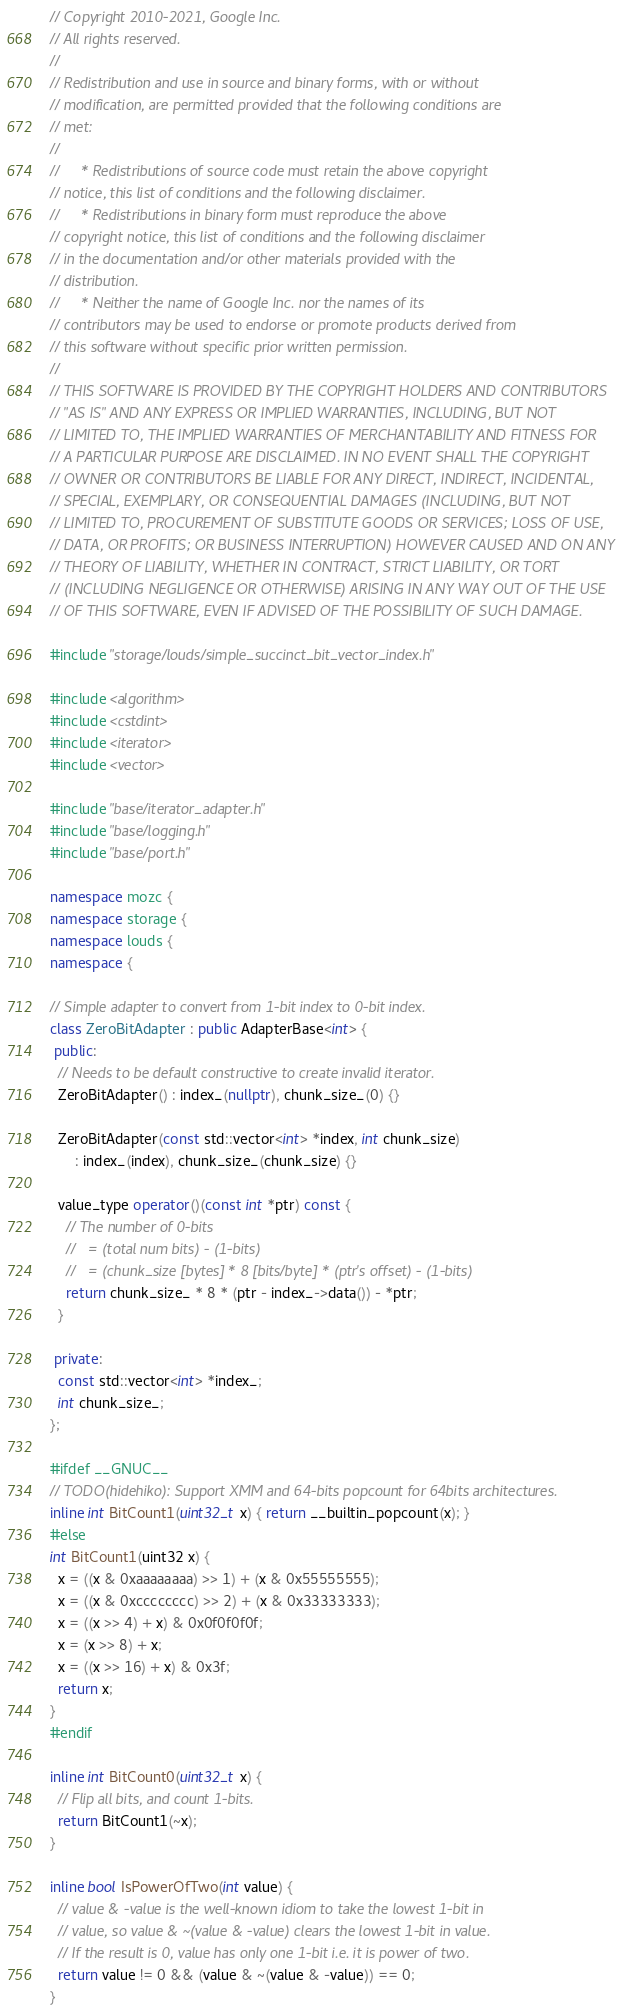<code> <loc_0><loc_0><loc_500><loc_500><_C++_>// Copyright 2010-2021, Google Inc.
// All rights reserved.
//
// Redistribution and use in source and binary forms, with or without
// modification, are permitted provided that the following conditions are
// met:
//
//     * Redistributions of source code must retain the above copyright
// notice, this list of conditions and the following disclaimer.
//     * Redistributions in binary form must reproduce the above
// copyright notice, this list of conditions and the following disclaimer
// in the documentation and/or other materials provided with the
// distribution.
//     * Neither the name of Google Inc. nor the names of its
// contributors may be used to endorse or promote products derived from
// this software without specific prior written permission.
//
// THIS SOFTWARE IS PROVIDED BY THE COPYRIGHT HOLDERS AND CONTRIBUTORS
// "AS IS" AND ANY EXPRESS OR IMPLIED WARRANTIES, INCLUDING, BUT NOT
// LIMITED TO, THE IMPLIED WARRANTIES OF MERCHANTABILITY AND FITNESS FOR
// A PARTICULAR PURPOSE ARE DISCLAIMED. IN NO EVENT SHALL THE COPYRIGHT
// OWNER OR CONTRIBUTORS BE LIABLE FOR ANY DIRECT, INDIRECT, INCIDENTAL,
// SPECIAL, EXEMPLARY, OR CONSEQUENTIAL DAMAGES (INCLUDING, BUT NOT
// LIMITED TO, PROCUREMENT OF SUBSTITUTE GOODS OR SERVICES; LOSS OF USE,
// DATA, OR PROFITS; OR BUSINESS INTERRUPTION) HOWEVER CAUSED AND ON ANY
// THEORY OF LIABILITY, WHETHER IN CONTRACT, STRICT LIABILITY, OR TORT
// (INCLUDING NEGLIGENCE OR OTHERWISE) ARISING IN ANY WAY OUT OF THE USE
// OF THIS SOFTWARE, EVEN IF ADVISED OF THE POSSIBILITY OF SUCH DAMAGE.

#include "storage/louds/simple_succinct_bit_vector_index.h"

#include <algorithm>
#include <cstdint>
#include <iterator>
#include <vector>

#include "base/iterator_adapter.h"
#include "base/logging.h"
#include "base/port.h"

namespace mozc {
namespace storage {
namespace louds {
namespace {

// Simple adapter to convert from 1-bit index to 0-bit index.
class ZeroBitAdapter : public AdapterBase<int> {
 public:
  // Needs to be default constructive to create invalid iterator.
  ZeroBitAdapter() : index_(nullptr), chunk_size_(0) {}

  ZeroBitAdapter(const std::vector<int> *index, int chunk_size)
      : index_(index), chunk_size_(chunk_size) {}

  value_type operator()(const int *ptr) const {
    // The number of 0-bits
    //   = (total num bits) - (1-bits)
    //   = (chunk_size [bytes] * 8 [bits/byte] * (ptr's offset) - (1-bits)
    return chunk_size_ * 8 * (ptr - index_->data()) - *ptr;
  }

 private:
  const std::vector<int> *index_;
  int chunk_size_;
};

#ifdef __GNUC__
// TODO(hidehiko): Support XMM and 64-bits popcount for 64bits architectures.
inline int BitCount1(uint32_t x) { return __builtin_popcount(x); }
#else
int BitCount1(uint32 x) {
  x = ((x & 0xaaaaaaaa) >> 1) + (x & 0x55555555);
  x = ((x & 0xcccccccc) >> 2) + (x & 0x33333333);
  x = ((x >> 4) + x) & 0x0f0f0f0f;
  x = (x >> 8) + x;
  x = ((x >> 16) + x) & 0x3f;
  return x;
}
#endif

inline int BitCount0(uint32_t x) {
  // Flip all bits, and count 1-bits.
  return BitCount1(~x);
}

inline bool IsPowerOfTwo(int value) {
  // value & -value is the well-known idiom to take the lowest 1-bit in
  // value, so value & ~(value & -value) clears the lowest 1-bit in value.
  // If the result is 0, value has only one 1-bit i.e. it is power of two.
  return value != 0 && (value & ~(value & -value)) == 0;
}
</code> 